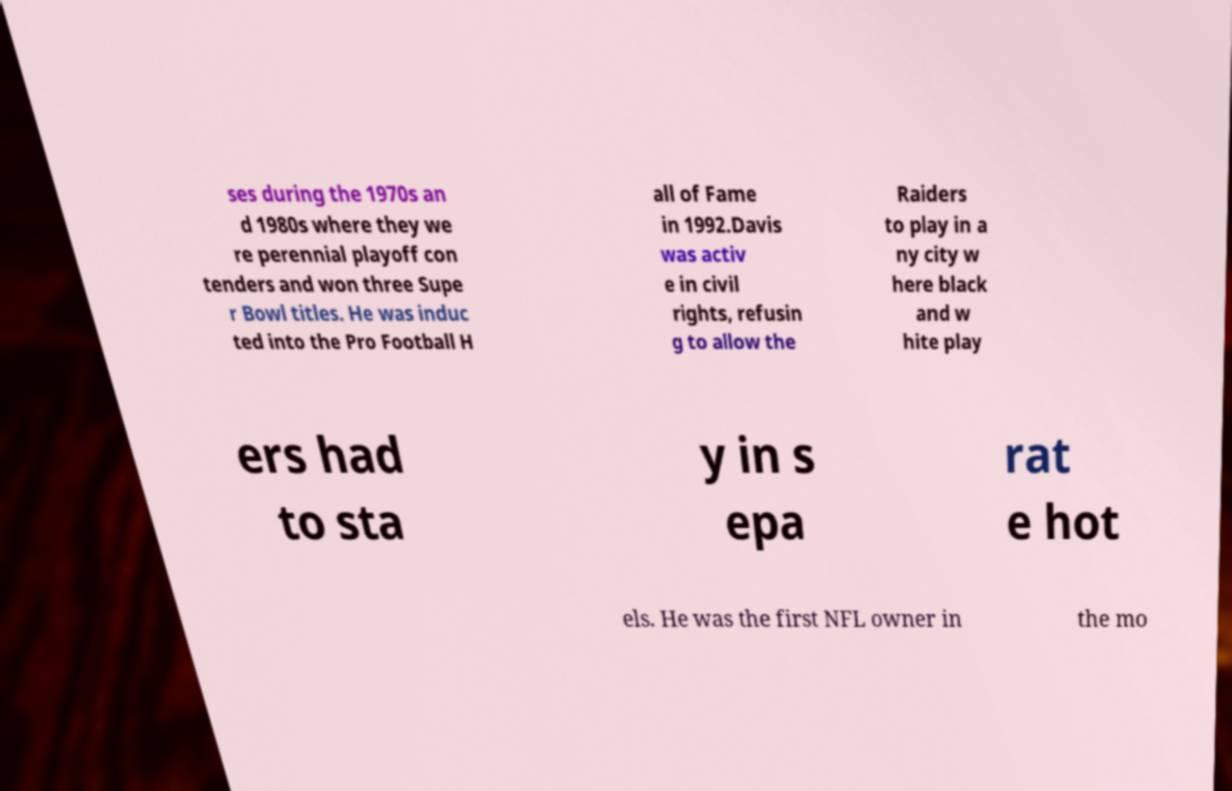I need the written content from this picture converted into text. Can you do that? ses during the 1970s an d 1980s where they we re perennial playoff con tenders and won three Supe r Bowl titles. He was induc ted into the Pro Football H all of Fame in 1992.Davis was activ e in civil rights, refusin g to allow the Raiders to play in a ny city w here black and w hite play ers had to sta y in s epa rat e hot els. He was the first NFL owner in the mo 